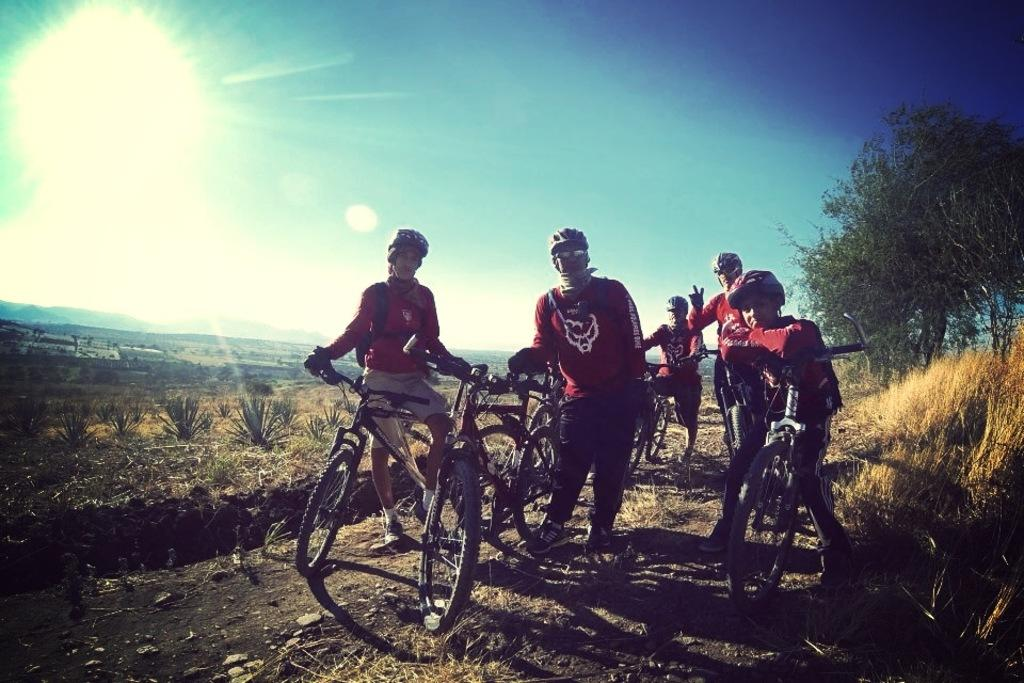What is the man near in the image? The man is standing near the bicycles. Are there any other people near the bicycles? Yes, there is a group of people standing near the bicycles. What can be seen in the background of the image? Plants, grass, trees, and the sky are visible in the background. Can the sun be seen in the image? Yes, the sun is visible in the sky. What type of quilt is being used to cover the house in the image? There is no quilt or house present in the image. What sound can be heard coming from the trees in the image? There is no sound present in the image, as it is a still photograph. 